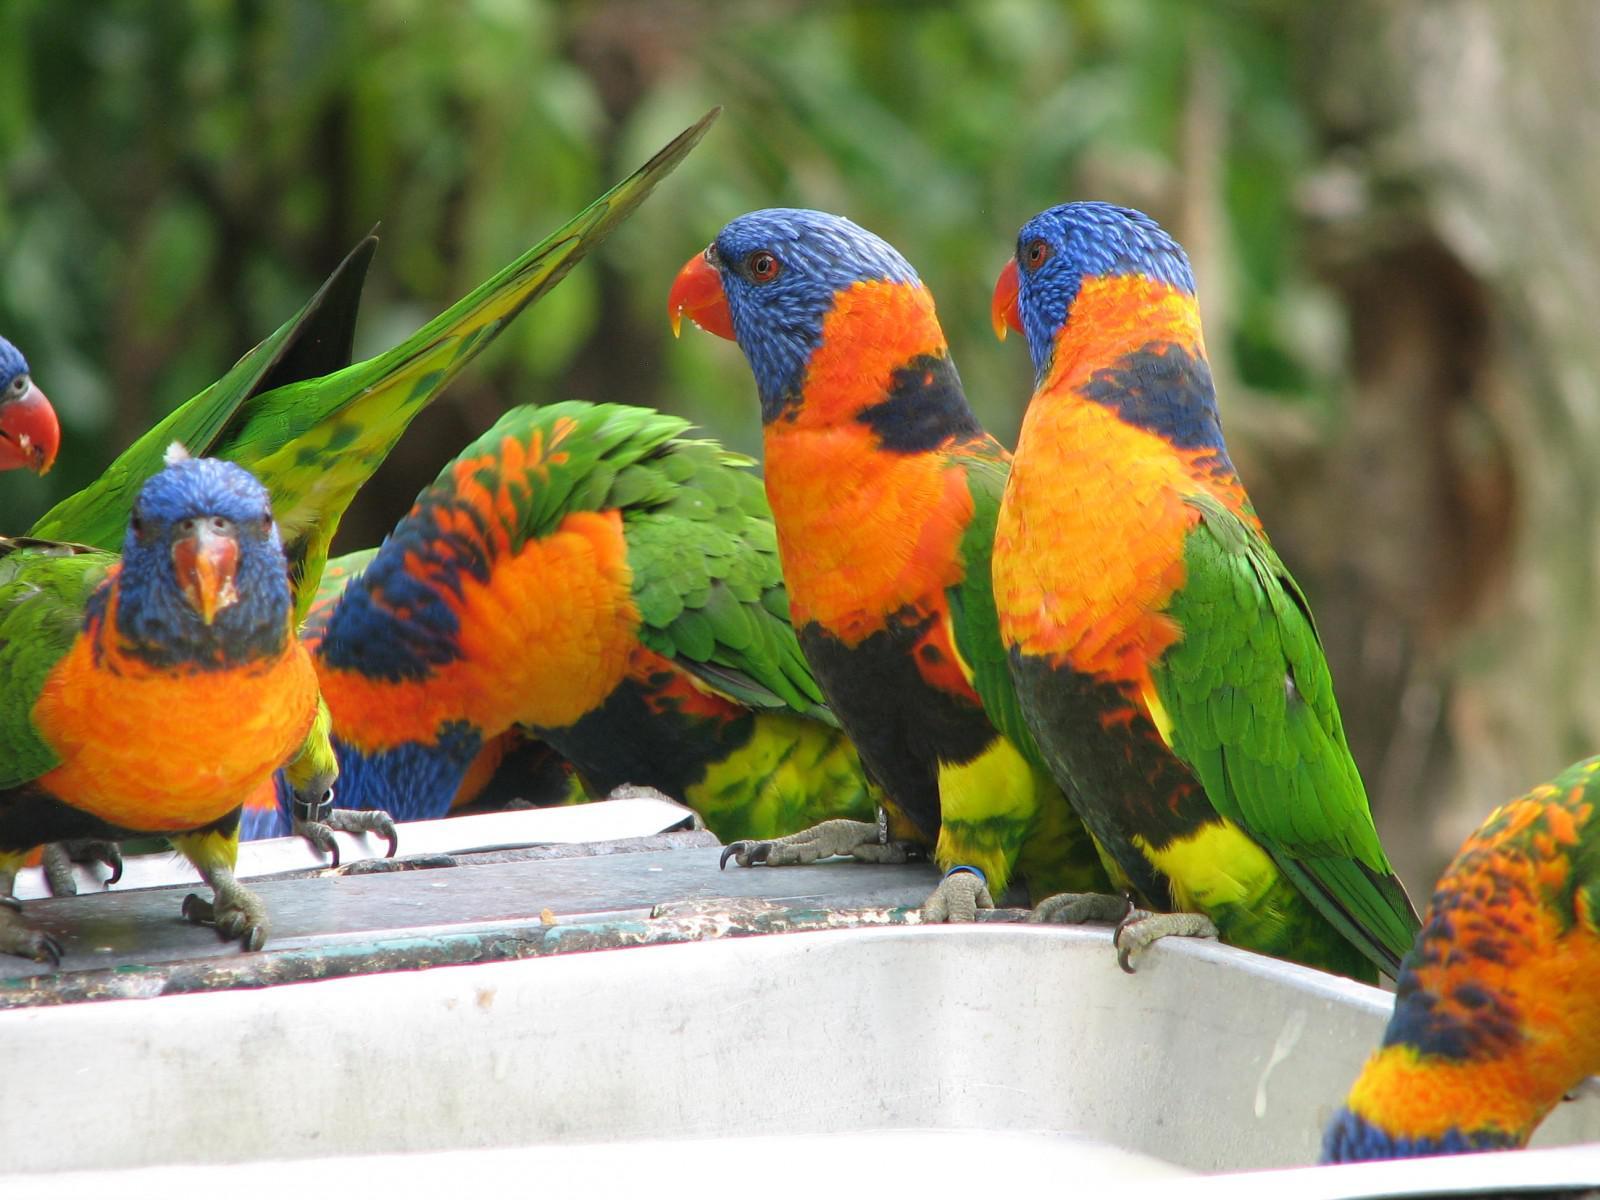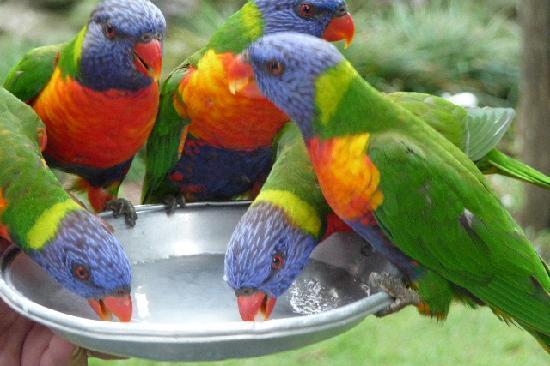The first image is the image on the left, the second image is the image on the right. Examine the images to the left and right. Is the description "There are lorikeets drinking from a silver, handheld bowl in the left image." accurate? Answer yes or no. No. The first image is the image on the left, the second image is the image on the right. Assess this claim about the two images: "Left image shows a hand holding a round pan from which multi-colored birds drink.". Correct or not? Answer yes or no. No. 